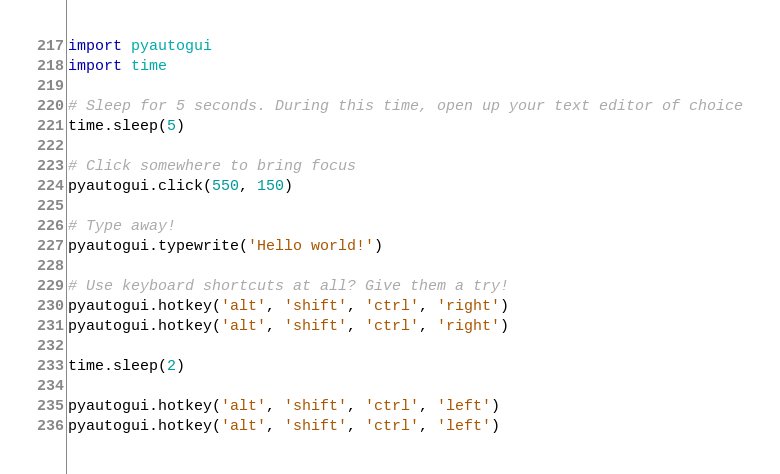Convert code to text. <code><loc_0><loc_0><loc_500><loc_500><_Python_>import pyautogui
import time

# Sleep for 5 seconds. During this time, open up your text editor of choice
time.sleep(5)

# Click somewhere to bring focus
pyautogui.click(550, 150)

# Type away!
pyautogui.typewrite('Hello world!')

# Use keyboard shortcuts at all? Give them a try!
pyautogui.hotkey('alt', 'shift', 'ctrl', 'right')
pyautogui.hotkey('alt', 'shift', 'ctrl', 'right')

time.sleep(2)

pyautogui.hotkey('alt', 'shift', 'ctrl', 'left')
pyautogui.hotkey('alt', 'shift', 'ctrl', 'left')</code> 